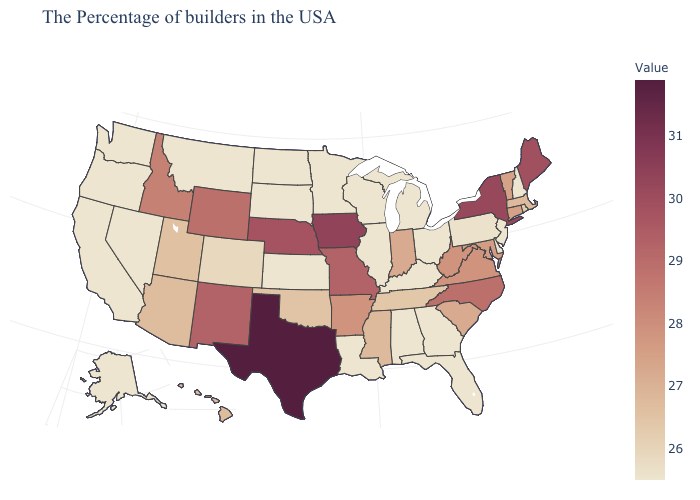Does Texas have the highest value in the USA?
Concise answer only. Yes. Among the states that border Iowa , does Nebraska have the highest value?
Give a very brief answer. Yes. Which states have the highest value in the USA?
Quick response, please. Texas. Which states have the highest value in the USA?
Concise answer only. Texas. Among the states that border South Dakota , which have the lowest value?
Give a very brief answer. Minnesota, North Dakota, Montana. 